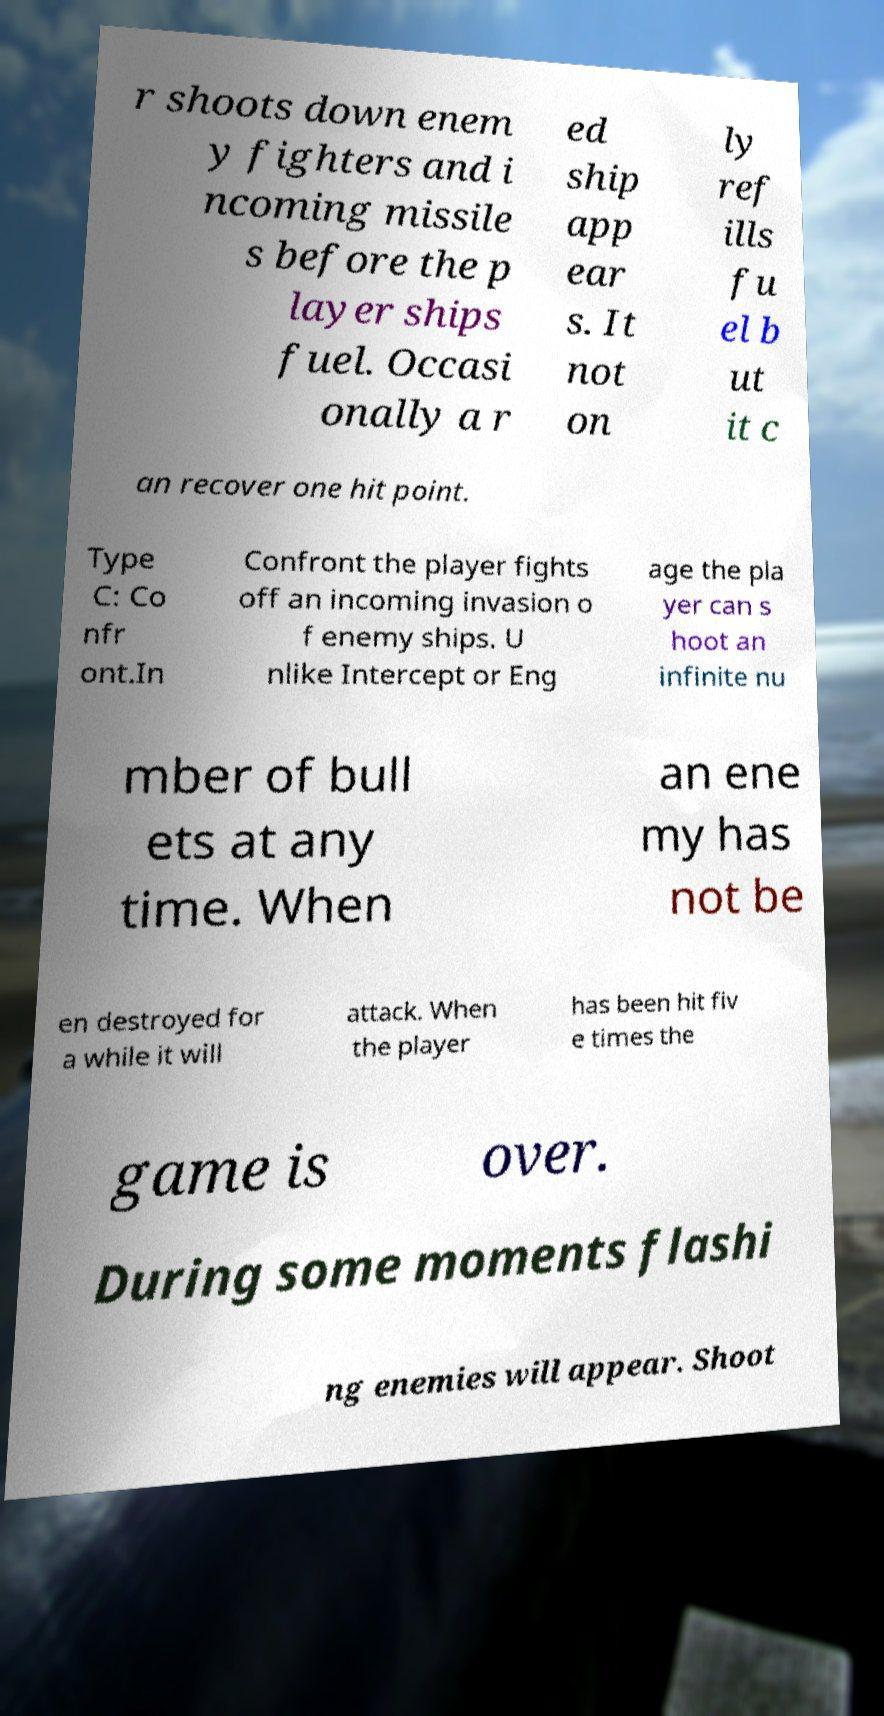Could you assist in decoding the text presented in this image and type it out clearly? r shoots down enem y fighters and i ncoming missile s before the p layer ships fuel. Occasi onally a r ed ship app ear s. It not on ly ref ills fu el b ut it c an recover one hit point. Type C: Co nfr ont.In Confront the player fights off an incoming invasion o f enemy ships. U nlike Intercept or Eng age the pla yer can s hoot an infinite nu mber of bull ets at any time. When an ene my has not be en destroyed for a while it will attack. When the player has been hit fiv e times the game is over. During some moments flashi ng enemies will appear. Shoot 